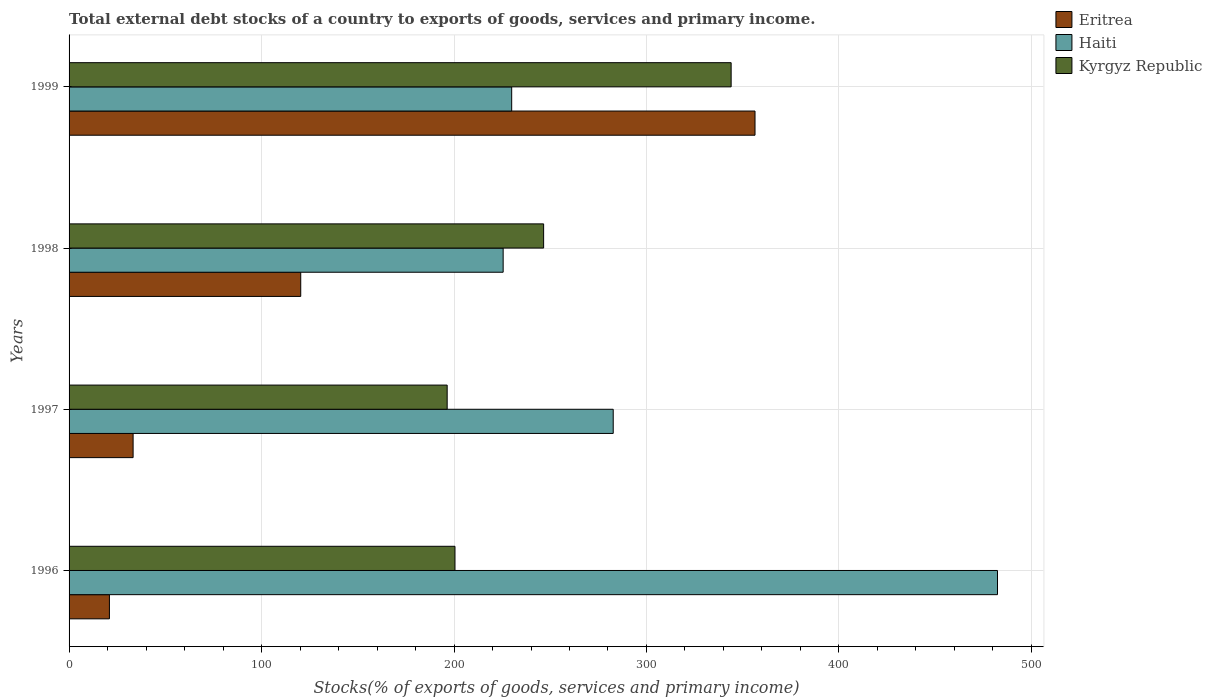How many different coloured bars are there?
Your answer should be very brief. 3. How many groups of bars are there?
Your response must be concise. 4. Are the number of bars per tick equal to the number of legend labels?
Keep it short and to the point. Yes. How many bars are there on the 1st tick from the bottom?
Make the answer very short. 3. What is the label of the 3rd group of bars from the top?
Keep it short and to the point. 1997. In how many cases, is the number of bars for a given year not equal to the number of legend labels?
Your response must be concise. 0. What is the total debt stocks in Kyrgyz Republic in 1999?
Your answer should be compact. 343.99. Across all years, what is the maximum total debt stocks in Kyrgyz Republic?
Offer a terse response. 343.99. Across all years, what is the minimum total debt stocks in Kyrgyz Republic?
Provide a short and direct response. 196.45. What is the total total debt stocks in Haiti in the graph?
Provide a short and direct response. 1220.61. What is the difference between the total debt stocks in Eritrea in 1996 and that in 1999?
Your answer should be very brief. -335.43. What is the difference between the total debt stocks in Kyrgyz Republic in 1998 and the total debt stocks in Haiti in 1997?
Offer a very short reply. -36.16. What is the average total debt stocks in Haiti per year?
Give a very brief answer. 305.15. In the year 1996, what is the difference between the total debt stocks in Eritrea and total debt stocks in Haiti?
Offer a very short reply. -461.41. In how many years, is the total debt stocks in Eritrea greater than 380 %?
Your response must be concise. 0. What is the ratio of the total debt stocks in Eritrea in 1997 to that in 1998?
Give a very brief answer. 0.28. Is the total debt stocks in Haiti in 1997 less than that in 1998?
Give a very brief answer. No. Is the difference between the total debt stocks in Eritrea in 1996 and 1998 greater than the difference between the total debt stocks in Haiti in 1996 and 1998?
Your response must be concise. No. What is the difference between the highest and the second highest total debt stocks in Haiti?
Make the answer very short. 199.66. What is the difference between the highest and the lowest total debt stocks in Eritrea?
Your response must be concise. 335.43. In how many years, is the total debt stocks in Kyrgyz Republic greater than the average total debt stocks in Kyrgyz Republic taken over all years?
Offer a terse response. 1. What does the 1st bar from the top in 1996 represents?
Your answer should be very brief. Kyrgyz Republic. What does the 1st bar from the bottom in 1996 represents?
Provide a succinct answer. Eritrea. Is it the case that in every year, the sum of the total debt stocks in Haiti and total debt stocks in Eritrea is greater than the total debt stocks in Kyrgyz Republic?
Keep it short and to the point. Yes. How many bars are there?
Offer a very short reply. 12. Are all the bars in the graph horizontal?
Offer a very short reply. Yes. Are the values on the major ticks of X-axis written in scientific E-notation?
Make the answer very short. No. Does the graph contain any zero values?
Give a very brief answer. No. How many legend labels are there?
Keep it short and to the point. 3. What is the title of the graph?
Your answer should be very brief. Total external debt stocks of a country to exports of goods, services and primary income. Does "Benin" appear as one of the legend labels in the graph?
Provide a succinct answer. No. What is the label or title of the X-axis?
Give a very brief answer. Stocks(% of exports of goods, services and primary income). What is the Stocks(% of exports of goods, services and primary income) in Eritrea in 1996?
Your response must be concise. 20.97. What is the Stocks(% of exports of goods, services and primary income) in Haiti in 1996?
Provide a short and direct response. 482.38. What is the Stocks(% of exports of goods, services and primary income) in Kyrgyz Republic in 1996?
Make the answer very short. 200.51. What is the Stocks(% of exports of goods, services and primary income) of Eritrea in 1997?
Provide a short and direct response. 33.27. What is the Stocks(% of exports of goods, services and primary income) in Haiti in 1997?
Give a very brief answer. 282.72. What is the Stocks(% of exports of goods, services and primary income) of Kyrgyz Republic in 1997?
Your answer should be very brief. 196.45. What is the Stocks(% of exports of goods, services and primary income) of Eritrea in 1998?
Provide a short and direct response. 120.36. What is the Stocks(% of exports of goods, services and primary income) of Haiti in 1998?
Ensure brevity in your answer.  225.54. What is the Stocks(% of exports of goods, services and primary income) in Kyrgyz Republic in 1998?
Offer a terse response. 246.56. What is the Stocks(% of exports of goods, services and primary income) in Eritrea in 1999?
Make the answer very short. 356.4. What is the Stocks(% of exports of goods, services and primary income) of Haiti in 1999?
Keep it short and to the point. 229.97. What is the Stocks(% of exports of goods, services and primary income) of Kyrgyz Republic in 1999?
Make the answer very short. 343.99. Across all years, what is the maximum Stocks(% of exports of goods, services and primary income) of Eritrea?
Provide a short and direct response. 356.4. Across all years, what is the maximum Stocks(% of exports of goods, services and primary income) in Haiti?
Make the answer very short. 482.38. Across all years, what is the maximum Stocks(% of exports of goods, services and primary income) of Kyrgyz Republic?
Offer a very short reply. 343.99. Across all years, what is the minimum Stocks(% of exports of goods, services and primary income) in Eritrea?
Your answer should be compact. 20.97. Across all years, what is the minimum Stocks(% of exports of goods, services and primary income) in Haiti?
Provide a short and direct response. 225.54. Across all years, what is the minimum Stocks(% of exports of goods, services and primary income) in Kyrgyz Republic?
Make the answer very short. 196.45. What is the total Stocks(% of exports of goods, services and primary income) of Eritrea in the graph?
Make the answer very short. 531. What is the total Stocks(% of exports of goods, services and primary income) in Haiti in the graph?
Offer a terse response. 1220.61. What is the total Stocks(% of exports of goods, services and primary income) in Kyrgyz Republic in the graph?
Offer a very short reply. 987.51. What is the difference between the Stocks(% of exports of goods, services and primary income) in Eritrea in 1996 and that in 1997?
Offer a terse response. -12.3. What is the difference between the Stocks(% of exports of goods, services and primary income) in Haiti in 1996 and that in 1997?
Provide a short and direct response. 199.66. What is the difference between the Stocks(% of exports of goods, services and primary income) of Kyrgyz Republic in 1996 and that in 1997?
Provide a succinct answer. 4.06. What is the difference between the Stocks(% of exports of goods, services and primary income) in Eritrea in 1996 and that in 1998?
Provide a succinct answer. -99.39. What is the difference between the Stocks(% of exports of goods, services and primary income) in Haiti in 1996 and that in 1998?
Your answer should be very brief. 256.84. What is the difference between the Stocks(% of exports of goods, services and primary income) in Kyrgyz Republic in 1996 and that in 1998?
Provide a succinct answer. -46.05. What is the difference between the Stocks(% of exports of goods, services and primary income) of Eritrea in 1996 and that in 1999?
Your response must be concise. -335.43. What is the difference between the Stocks(% of exports of goods, services and primary income) in Haiti in 1996 and that in 1999?
Provide a short and direct response. 252.41. What is the difference between the Stocks(% of exports of goods, services and primary income) in Kyrgyz Republic in 1996 and that in 1999?
Offer a very short reply. -143.48. What is the difference between the Stocks(% of exports of goods, services and primary income) in Eritrea in 1997 and that in 1998?
Make the answer very short. -87.09. What is the difference between the Stocks(% of exports of goods, services and primary income) in Haiti in 1997 and that in 1998?
Offer a very short reply. 57.18. What is the difference between the Stocks(% of exports of goods, services and primary income) of Kyrgyz Republic in 1997 and that in 1998?
Provide a succinct answer. -50.11. What is the difference between the Stocks(% of exports of goods, services and primary income) of Eritrea in 1997 and that in 1999?
Your answer should be very brief. -323.12. What is the difference between the Stocks(% of exports of goods, services and primary income) in Haiti in 1997 and that in 1999?
Give a very brief answer. 52.75. What is the difference between the Stocks(% of exports of goods, services and primary income) in Kyrgyz Republic in 1997 and that in 1999?
Make the answer very short. -147.54. What is the difference between the Stocks(% of exports of goods, services and primary income) of Eritrea in 1998 and that in 1999?
Provide a succinct answer. -236.03. What is the difference between the Stocks(% of exports of goods, services and primary income) in Haiti in 1998 and that in 1999?
Keep it short and to the point. -4.43. What is the difference between the Stocks(% of exports of goods, services and primary income) of Kyrgyz Republic in 1998 and that in 1999?
Provide a succinct answer. -97.43. What is the difference between the Stocks(% of exports of goods, services and primary income) of Eritrea in 1996 and the Stocks(% of exports of goods, services and primary income) of Haiti in 1997?
Make the answer very short. -261.75. What is the difference between the Stocks(% of exports of goods, services and primary income) of Eritrea in 1996 and the Stocks(% of exports of goods, services and primary income) of Kyrgyz Republic in 1997?
Make the answer very short. -175.48. What is the difference between the Stocks(% of exports of goods, services and primary income) of Haiti in 1996 and the Stocks(% of exports of goods, services and primary income) of Kyrgyz Republic in 1997?
Your answer should be very brief. 285.93. What is the difference between the Stocks(% of exports of goods, services and primary income) of Eritrea in 1996 and the Stocks(% of exports of goods, services and primary income) of Haiti in 1998?
Your response must be concise. -204.57. What is the difference between the Stocks(% of exports of goods, services and primary income) of Eritrea in 1996 and the Stocks(% of exports of goods, services and primary income) of Kyrgyz Republic in 1998?
Provide a short and direct response. -225.59. What is the difference between the Stocks(% of exports of goods, services and primary income) of Haiti in 1996 and the Stocks(% of exports of goods, services and primary income) of Kyrgyz Republic in 1998?
Your response must be concise. 235.82. What is the difference between the Stocks(% of exports of goods, services and primary income) of Eritrea in 1996 and the Stocks(% of exports of goods, services and primary income) of Haiti in 1999?
Offer a terse response. -209. What is the difference between the Stocks(% of exports of goods, services and primary income) in Eritrea in 1996 and the Stocks(% of exports of goods, services and primary income) in Kyrgyz Republic in 1999?
Offer a terse response. -323.02. What is the difference between the Stocks(% of exports of goods, services and primary income) of Haiti in 1996 and the Stocks(% of exports of goods, services and primary income) of Kyrgyz Republic in 1999?
Your answer should be compact. 138.39. What is the difference between the Stocks(% of exports of goods, services and primary income) in Eritrea in 1997 and the Stocks(% of exports of goods, services and primary income) in Haiti in 1998?
Make the answer very short. -192.27. What is the difference between the Stocks(% of exports of goods, services and primary income) in Eritrea in 1997 and the Stocks(% of exports of goods, services and primary income) in Kyrgyz Republic in 1998?
Your answer should be compact. -213.29. What is the difference between the Stocks(% of exports of goods, services and primary income) in Haiti in 1997 and the Stocks(% of exports of goods, services and primary income) in Kyrgyz Republic in 1998?
Provide a succinct answer. 36.16. What is the difference between the Stocks(% of exports of goods, services and primary income) of Eritrea in 1997 and the Stocks(% of exports of goods, services and primary income) of Haiti in 1999?
Provide a short and direct response. -196.7. What is the difference between the Stocks(% of exports of goods, services and primary income) of Eritrea in 1997 and the Stocks(% of exports of goods, services and primary income) of Kyrgyz Republic in 1999?
Offer a very short reply. -310.72. What is the difference between the Stocks(% of exports of goods, services and primary income) in Haiti in 1997 and the Stocks(% of exports of goods, services and primary income) in Kyrgyz Republic in 1999?
Your answer should be very brief. -61.27. What is the difference between the Stocks(% of exports of goods, services and primary income) of Eritrea in 1998 and the Stocks(% of exports of goods, services and primary income) of Haiti in 1999?
Offer a terse response. -109.61. What is the difference between the Stocks(% of exports of goods, services and primary income) in Eritrea in 1998 and the Stocks(% of exports of goods, services and primary income) in Kyrgyz Republic in 1999?
Offer a terse response. -223.63. What is the difference between the Stocks(% of exports of goods, services and primary income) in Haiti in 1998 and the Stocks(% of exports of goods, services and primary income) in Kyrgyz Republic in 1999?
Your answer should be very brief. -118.45. What is the average Stocks(% of exports of goods, services and primary income) of Eritrea per year?
Your answer should be very brief. 132.75. What is the average Stocks(% of exports of goods, services and primary income) in Haiti per year?
Give a very brief answer. 305.15. What is the average Stocks(% of exports of goods, services and primary income) of Kyrgyz Republic per year?
Your answer should be very brief. 246.88. In the year 1996, what is the difference between the Stocks(% of exports of goods, services and primary income) of Eritrea and Stocks(% of exports of goods, services and primary income) of Haiti?
Provide a succinct answer. -461.41. In the year 1996, what is the difference between the Stocks(% of exports of goods, services and primary income) of Eritrea and Stocks(% of exports of goods, services and primary income) of Kyrgyz Republic?
Ensure brevity in your answer.  -179.54. In the year 1996, what is the difference between the Stocks(% of exports of goods, services and primary income) in Haiti and Stocks(% of exports of goods, services and primary income) in Kyrgyz Republic?
Make the answer very short. 281.87. In the year 1997, what is the difference between the Stocks(% of exports of goods, services and primary income) of Eritrea and Stocks(% of exports of goods, services and primary income) of Haiti?
Keep it short and to the point. -249.45. In the year 1997, what is the difference between the Stocks(% of exports of goods, services and primary income) in Eritrea and Stocks(% of exports of goods, services and primary income) in Kyrgyz Republic?
Your response must be concise. -163.18. In the year 1997, what is the difference between the Stocks(% of exports of goods, services and primary income) in Haiti and Stocks(% of exports of goods, services and primary income) in Kyrgyz Republic?
Your answer should be compact. 86.27. In the year 1998, what is the difference between the Stocks(% of exports of goods, services and primary income) in Eritrea and Stocks(% of exports of goods, services and primary income) in Haiti?
Give a very brief answer. -105.18. In the year 1998, what is the difference between the Stocks(% of exports of goods, services and primary income) of Eritrea and Stocks(% of exports of goods, services and primary income) of Kyrgyz Republic?
Offer a terse response. -126.2. In the year 1998, what is the difference between the Stocks(% of exports of goods, services and primary income) of Haiti and Stocks(% of exports of goods, services and primary income) of Kyrgyz Republic?
Your answer should be compact. -21.02. In the year 1999, what is the difference between the Stocks(% of exports of goods, services and primary income) of Eritrea and Stocks(% of exports of goods, services and primary income) of Haiti?
Provide a succinct answer. 126.43. In the year 1999, what is the difference between the Stocks(% of exports of goods, services and primary income) in Eritrea and Stocks(% of exports of goods, services and primary income) in Kyrgyz Republic?
Keep it short and to the point. 12.4. In the year 1999, what is the difference between the Stocks(% of exports of goods, services and primary income) of Haiti and Stocks(% of exports of goods, services and primary income) of Kyrgyz Republic?
Keep it short and to the point. -114.02. What is the ratio of the Stocks(% of exports of goods, services and primary income) in Eritrea in 1996 to that in 1997?
Make the answer very short. 0.63. What is the ratio of the Stocks(% of exports of goods, services and primary income) of Haiti in 1996 to that in 1997?
Make the answer very short. 1.71. What is the ratio of the Stocks(% of exports of goods, services and primary income) of Kyrgyz Republic in 1996 to that in 1997?
Your response must be concise. 1.02. What is the ratio of the Stocks(% of exports of goods, services and primary income) of Eritrea in 1996 to that in 1998?
Your response must be concise. 0.17. What is the ratio of the Stocks(% of exports of goods, services and primary income) in Haiti in 1996 to that in 1998?
Provide a short and direct response. 2.14. What is the ratio of the Stocks(% of exports of goods, services and primary income) of Kyrgyz Republic in 1996 to that in 1998?
Offer a very short reply. 0.81. What is the ratio of the Stocks(% of exports of goods, services and primary income) in Eritrea in 1996 to that in 1999?
Provide a short and direct response. 0.06. What is the ratio of the Stocks(% of exports of goods, services and primary income) in Haiti in 1996 to that in 1999?
Offer a very short reply. 2.1. What is the ratio of the Stocks(% of exports of goods, services and primary income) in Kyrgyz Republic in 1996 to that in 1999?
Your answer should be very brief. 0.58. What is the ratio of the Stocks(% of exports of goods, services and primary income) of Eritrea in 1997 to that in 1998?
Your answer should be very brief. 0.28. What is the ratio of the Stocks(% of exports of goods, services and primary income) of Haiti in 1997 to that in 1998?
Provide a succinct answer. 1.25. What is the ratio of the Stocks(% of exports of goods, services and primary income) in Kyrgyz Republic in 1997 to that in 1998?
Give a very brief answer. 0.8. What is the ratio of the Stocks(% of exports of goods, services and primary income) in Eritrea in 1997 to that in 1999?
Offer a very short reply. 0.09. What is the ratio of the Stocks(% of exports of goods, services and primary income) in Haiti in 1997 to that in 1999?
Your answer should be compact. 1.23. What is the ratio of the Stocks(% of exports of goods, services and primary income) of Kyrgyz Republic in 1997 to that in 1999?
Provide a short and direct response. 0.57. What is the ratio of the Stocks(% of exports of goods, services and primary income) of Eritrea in 1998 to that in 1999?
Provide a succinct answer. 0.34. What is the ratio of the Stocks(% of exports of goods, services and primary income) in Haiti in 1998 to that in 1999?
Ensure brevity in your answer.  0.98. What is the ratio of the Stocks(% of exports of goods, services and primary income) in Kyrgyz Republic in 1998 to that in 1999?
Provide a short and direct response. 0.72. What is the difference between the highest and the second highest Stocks(% of exports of goods, services and primary income) in Eritrea?
Give a very brief answer. 236.03. What is the difference between the highest and the second highest Stocks(% of exports of goods, services and primary income) of Haiti?
Your answer should be very brief. 199.66. What is the difference between the highest and the second highest Stocks(% of exports of goods, services and primary income) of Kyrgyz Republic?
Your answer should be very brief. 97.43. What is the difference between the highest and the lowest Stocks(% of exports of goods, services and primary income) of Eritrea?
Your answer should be very brief. 335.43. What is the difference between the highest and the lowest Stocks(% of exports of goods, services and primary income) of Haiti?
Provide a short and direct response. 256.84. What is the difference between the highest and the lowest Stocks(% of exports of goods, services and primary income) of Kyrgyz Republic?
Keep it short and to the point. 147.54. 